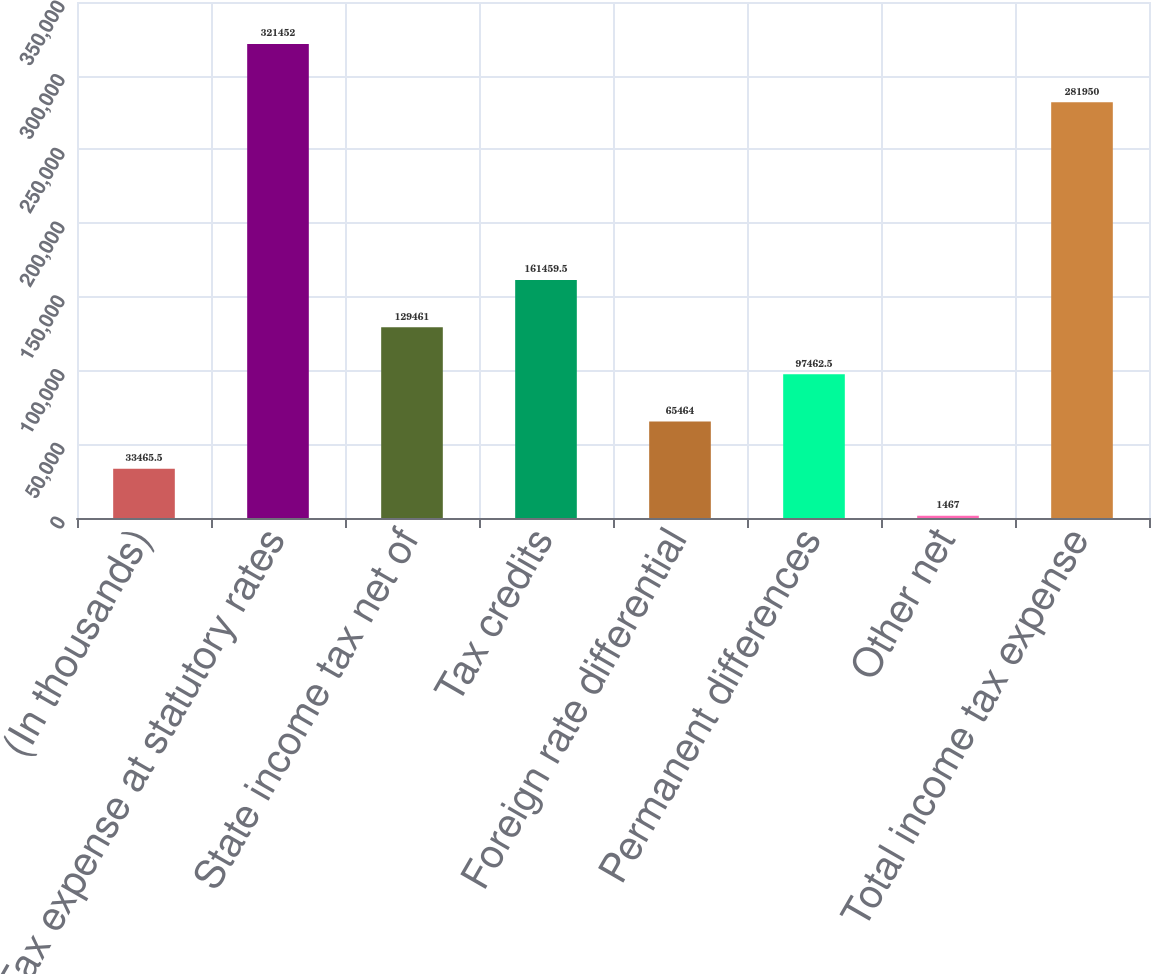Convert chart to OTSL. <chart><loc_0><loc_0><loc_500><loc_500><bar_chart><fcel>(In thousands)<fcel>Tax expense at statutory rates<fcel>State income tax net of<fcel>Tax credits<fcel>Foreign rate differential<fcel>Permanent differences<fcel>Other net<fcel>Total income tax expense<nl><fcel>33465.5<fcel>321452<fcel>129461<fcel>161460<fcel>65464<fcel>97462.5<fcel>1467<fcel>281950<nl></chart> 